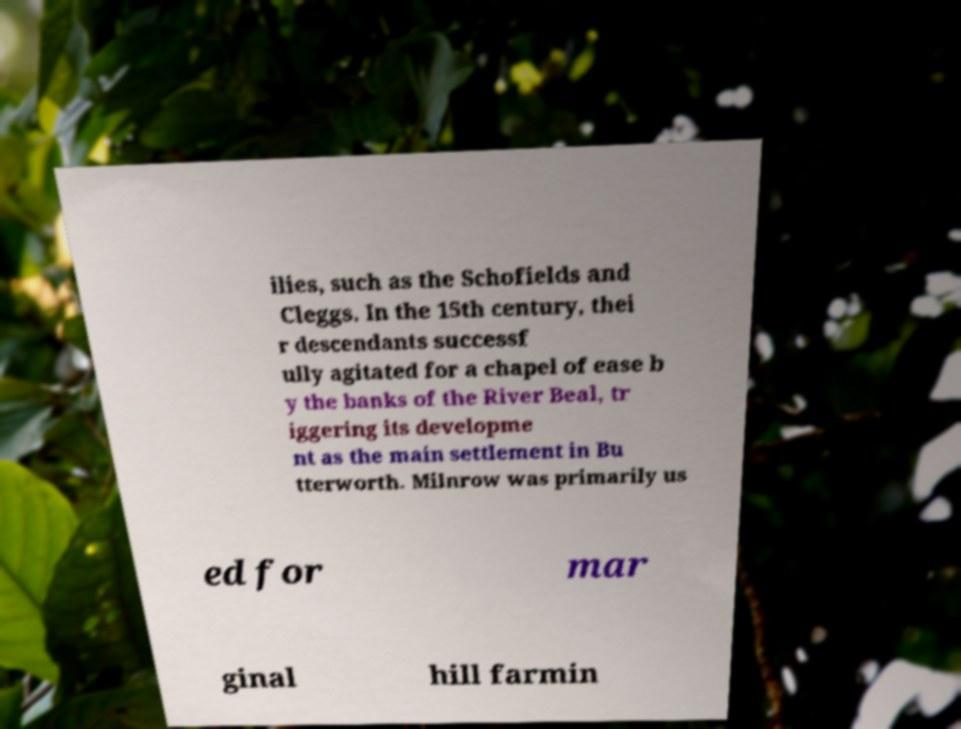I need the written content from this picture converted into text. Can you do that? ilies, such as the Schofields and Cleggs. In the 15th century, thei r descendants successf ully agitated for a chapel of ease b y the banks of the River Beal, tr iggering its developme nt as the main settlement in Bu tterworth. Milnrow was primarily us ed for mar ginal hill farmin 